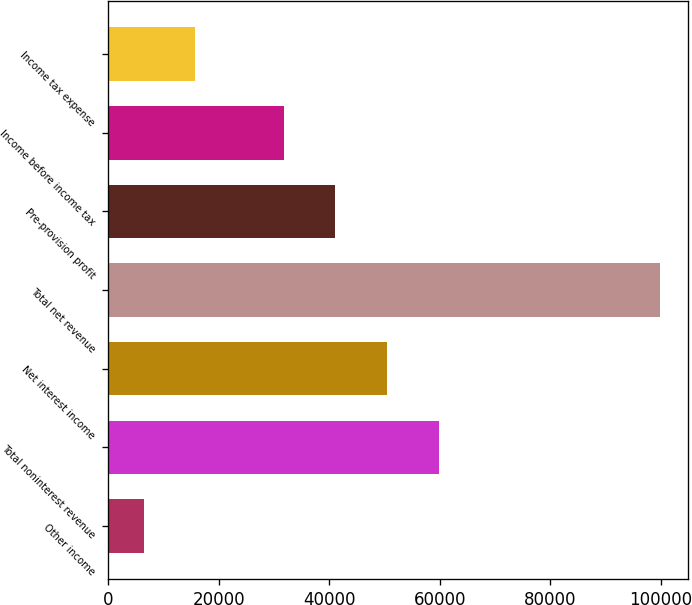Convert chart to OTSL. <chart><loc_0><loc_0><loc_500><loc_500><bar_chart><fcel>Other income<fcel>Total noninterest revenue<fcel>Net interest income<fcel>Total net revenue<fcel>Pre-provision profit<fcel>Income before income tax<fcel>Income tax expense<nl><fcel>6374<fcel>59830.8<fcel>50479.2<fcel>99890<fcel>41127.6<fcel>31776<fcel>15725.6<nl></chart> 